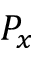Convert formula to latex. <formula><loc_0><loc_0><loc_500><loc_500>P _ { x }</formula> 